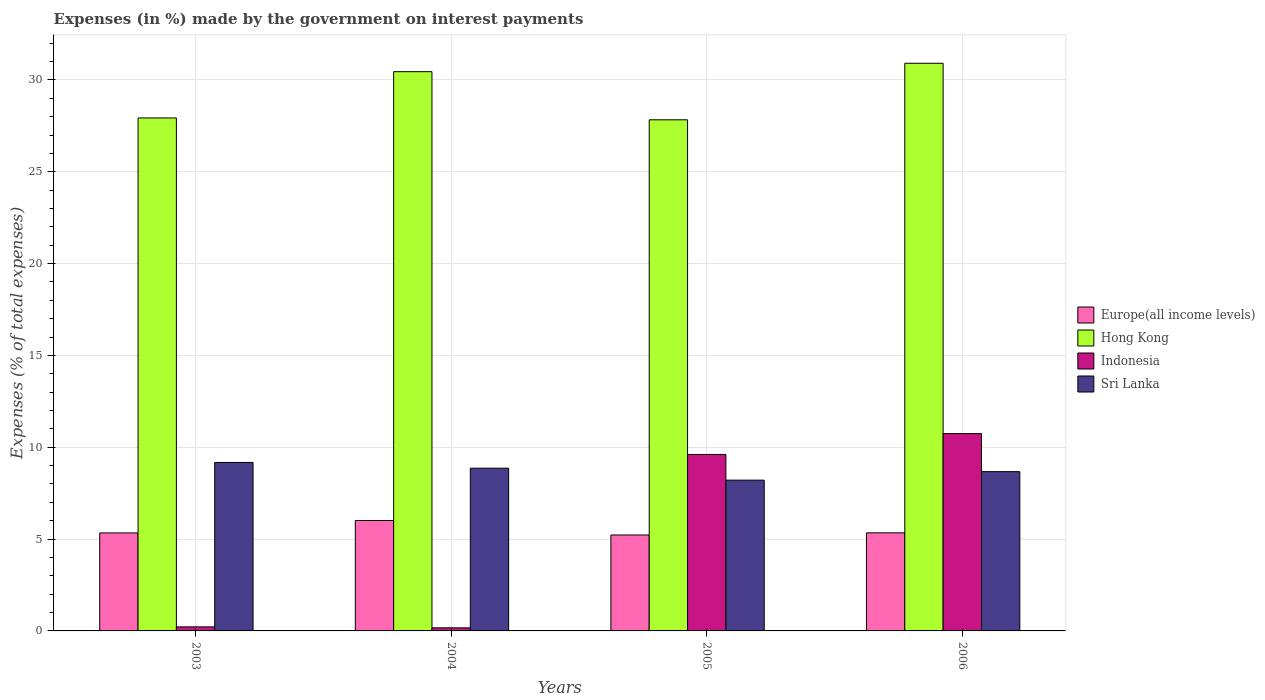How many different coloured bars are there?
Your answer should be very brief. 4. How many groups of bars are there?
Offer a terse response. 4. Are the number of bars on each tick of the X-axis equal?
Provide a succinct answer. Yes. How many bars are there on the 3rd tick from the left?
Keep it short and to the point. 4. How many bars are there on the 1st tick from the right?
Offer a terse response. 4. In how many cases, is the number of bars for a given year not equal to the number of legend labels?
Your response must be concise. 0. What is the percentage of expenses made by the government on interest payments in Indonesia in 2004?
Your answer should be very brief. 0.17. Across all years, what is the maximum percentage of expenses made by the government on interest payments in Indonesia?
Your answer should be very brief. 10.74. Across all years, what is the minimum percentage of expenses made by the government on interest payments in Sri Lanka?
Offer a very short reply. 8.21. In which year was the percentage of expenses made by the government on interest payments in Sri Lanka minimum?
Offer a terse response. 2005. What is the total percentage of expenses made by the government on interest payments in Europe(all income levels) in the graph?
Your answer should be compact. 21.91. What is the difference between the percentage of expenses made by the government on interest payments in Hong Kong in 2005 and that in 2006?
Give a very brief answer. -3.08. What is the difference between the percentage of expenses made by the government on interest payments in Sri Lanka in 2006 and the percentage of expenses made by the government on interest payments in Hong Kong in 2004?
Offer a terse response. -21.78. What is the average percentage of expenses made by the government on interest payments in Hong Kong per year?
Your answer should be compact. 29.28. In the year 2006, what is the difference between the percentage of expenses made by the government on interest payments in Europe(all income levels) and percentage of expenses made by the government on interest payments in Indonesia?
Your answer should be very brief. -5.4. What is the ratio of the percentage of expenses made by the government on interest payments in Europe(all income levels) in 2003 to that in 2005?
Provide a short and direct response. 1.02. Is the percentage of expenses made by the government on interest payments in Indonesia in 2004 less than that in 2006?
Your response must be concise. Yes. What is the difference between the highest and the second highest percentage of expenses made by the government on interest payments in Indonesia?
Provide a short and direct response. 1.14. What is the difference between the highest and the lowest percentage of expenses made by the government on interest payments in Europe(all income levels)?
Keep it short and to the point. 0.79. Is the sum of the percentage of expenses made by the government on interest payments in Hong Kong in 2004 and 2006 greater than the maximum percentage of expenses made by the government on interest payments in Sri Lanka across all years?
Ensure brevity in your answer.  Yes. Is it the case that in every year, the sum of the percentage of expenses made by the government on interest payments in Indonesia and percentage of expenses made by the government on interest payments in Europe(all income levels) is greater than the sum of percentage of expenses made by the government on interest payments in Hong Kong and percentage of expenses made by the government on interest payments in Sri Lanka?
Give a very brief answer. Yes. What does the 4th bar from the left in 2004 represents?
Ensure brevity in your answer.  Sri Lanka. What does the 4th bar from the right in 2004 represents?
Offer a terse response. Europe(all income levels). Is it the case that in every year, the sum of the percentage of expenses made by the government on interest payments in Hong Kong and percentage of expenses made by the government on interest payments in Indonesia is greater than the percentage of expenses made by the government on interest payments in Europe(all income levels)?
Make the answer very short. Yes. How many years are there in the graph?
Ensure brevity in your answer.  4. What is the difference between two consecutive major ticks on the Y-axis?
Provide a succinct answer. 5. Are the values on the major ticks of Y-axis written in scientific E-notation?
Your response must be concise. No. Does the graph contain grids?
Keep it short and to the point. Yes. Where does the legend appear in the graph?
Provide a succinct answer. Center right. How many legend labels are there?
Your response must be concise. 4. How are the legend labels stacked?
Keep it short and to the point. Vertical. What is the title of the graph?
Give a very brief answer. Expenses (in %) made by the government on interest payments. What is the label or title of the Y-axis?
Ensure brevity in your answer.  Expenses (% of total expenses). What is the Expenses (% of total expenses) in Europe(all income levels) in 2003?
Give a very brief answer. 5.34. What is the Expenses (% of total expenses) of Hong Kong in 2003?
Your response must be concise. 27.93. What is the Expenses (% of total expenses) of Indonesia in 2003?
Give a very brief answer. 0.22. What is the Expenses (% of total expenses) in Sri Lanka in 2003?
Your answer should be compact. 9.17. What is the Expenses (% of total expenses) of Europe(all income levels) in 2004?
Ensure brevity in your answer.  6.01. What is the Expenses (% of total expenses) in Hong Kong in 2004?
Keep it short and to the point. 30.45. What is the Expenses (% of total expenses) in Indonesia in 2004?
Your answer should be compact. 0.17. What is the Expenses (% of total expenses) in Sri Lanka in 2004?
Your answer should be very brief. 8.86. What is the Expenses (% of total expenses) of Europe(all income levels) in 2005?
Provide a short and direct response. 5.22. What is the Expenses (% of total expenses) of Hong Kong in 2005?
Offer a very short reply. 27.83. What is the Expenses (% of total expenses) of Indonesia in 2005?
Provide a succinct answer. 9.61. What is the Expenses (% of total expenses) of Sri Lanka in 2005?
Your answer should be very brief. 8.21. What is the Expenses (% of total expenses) of Europe(all income levels) in 2006?
Your answer should be compact. 5.34. What is the Expenses (% of total expenses) of Hong Kong in 2006?
Ensure brevity in your answer.  30.91. What is the Expenses (% of total expenses) of Indonesia in 2006?
Ensure brevity in your answer.  10.74. What is the Expenses (% of total expenses) in Sri Lanka in 2006?
Give a very brief answer. 8.67. Across all years, what is the maximum Expenses (% of total expenses) of Europe(all income levels)?
Keep it short and to the point. 6.01. Across all years, what is the maximum Expenses (% of total expenses) of Hong Kong?
Make the answer very short. 30.91. Across all years, what is the maximum Expenses (% of total expenses) in Indonesia?
Your answer should be compact. 10.74. Across all years, what is the maximum Expenses (% of total expenses) of Sri Lanka?
Provide a short and direct response. 9.17. Across all years, what is the minimum Expenses (% of total expenses) of Europe(all income levels)?
Provide a short and direct response. 5.22. Across all years, what is the minimum Expenses (% of total expenses) of Hong Kong?
Your response must be concise. 27.83. Across all years, what is the minimum Expenses (% of total expenses) in Indonesia?
Make the answer very short. 0.17. Across all years, what is the minimum Expenses (% of total expenses) of Sri Lanka?
Give a very brief answer. 8.21. What is the total Expenses (% of total expenses) of Europe(all income levels) in the graph?
Keep it short and to the point. 21.91. What is the total Expenses (% of total expenses) of Hong Kong in the graph?
Offer a very short reply. 117.12. What is the total Expenses (% of total expenses) of Indonesia in the graph?
Provide a short and direct response. 20.74. What is the total Expenses (% of total expenses) of Sri Lanka in the graph?
Your answer should be very brief. 34.92. What is the difference between the Expenses (% of total expenses) of Europe(all income levels) in 2003 and that in 2004?
Your answer should be compact. -0.68. What is the difference between the Expenses (% of total expenses) of Hong Kong in 2003 and that in 2004?
Give a very brief answer. -2.52. What is the difference between the Expenses (% of total expenses) of Indonesia in 2003 and that in 2004?
Make the answer very short. 0.05. What is the difference between the Expenses (% of total expenses) in Sri Lanka in 2003 and that in 2004?
Offer a terse response. 0.31. What is the difference between the Expenses (% of total expenses) of Europe(all income levels) in 2003 and that in 2005?
Your answer should be compact. 0.11. What is the difference between the Expenses (% of total expenses) of Hong Kong in 2003 and that in 2005?
Your response must be concise. 0.1. What is the difference between the Expenses (% of total expenses) of Indonesia in 2003 and that in 2005?
Offer a very short reply. -9.39. What is the difference between the Expenses (% of total expenses) in Sri Lanka in 2003 and that in 2005?
Provide a short and direct response. 0.96. What is the difference between the Expenses (% of total expenses) of Europe(all income levels) in 2003 and that in 2006?
Ensure brevity in your answer.  -0.01. What is the difference between the Expenses (% of total expenses) of Hong Kong in 2003 and that in 2006?
Provide a succinct answer. -2.98. What is the difference between the Expenses (% of total expenses) of Indonesia in 2003 and that in 2006?
Offer a very short reply. -10.53. What is the difference between the Expenses (% of total expenses) of Sri Lanka in 2003 and that in 2006?
Ensure brevity in your answer.  0.5. What is the difference between the Expenses (% of total expenses) in Europe(all income levels) in 2004 and that in 2005?
Your answer should be very brief. 0.79. What is the difference between the Expenses (% of total expenses) of Hong Kong in 2004 and that in 2005?
Offer a terse response. 2.62. What is the difference between the Expenses (% of total expenses) of Indonesia in 2004 and that in 2005?
Ensure brevity in your answer.  -9.44. What is the difference between the Expenses (% of total expenses) of Sri Lanka in 2004 and that in 2005?
Offer a very short reply. 0.65. What is the difference between the Expenses (% of total expenses) of Europe(all income levels) in 2004 and that in 2006?
Give a very brief answer. 0.67. What is the difference between the Expenses (% of total expenses) in Hong Kong in 2004 and that in 2006?
Your response must be concise. -0.46. What is the difference between the Expenses (% of total expenses) of Indonesia in 2004 and that in 2006?
Provide a short and direct response. -10.58. What is the difference between the Expenses (% of total expenses) of Sri Lanka in 2004 and that in 2006?
Provide a succinct answer. 0.19. What is the difference between the Expenses (% of total expenses) of Europe(all income levels) in 2005 and that in 2006?
Your answer should be compact. -0.12. What is the difference between the Expenses (% of total expenses) in Hong Kong in 2005 and that in 2006?
Provide a short and direct response. -3.08. What is the difference between the Expenses (% of total expenses) of Indonesia in 2005 and that in 2006?
Ensure brevity in your answer.  -1.14. What is the difference between the Expenses (% of total expenses) in Sri Lanka in 2005 and that in 2006?
Give a very brief answer. -0.46. What is the difference between the Expenses (% of total expenses) in Europe(all income levels) in 2003 and the Expenses (% of total expenses) in Hong Kong in 2004?
Provide a succinct answer. -25.12. What is the difference between the Expenses (% of total expenses) in Europe(all income levels) in 2003 and the Expenses (% of total expenses) in Indonesia in 2004?
Offer a terse response. 5.17. What is the difference between the Expenses (% of total expenses) in Europe(all income levels) in 2003 and the Expenses (% of total expenses) in Sri Lanka in 2004?
Make the answer very short. -3.53. What is the difference between the Expenses (% of total expenses) in Hong Kong in 2003 and the Expenses (% of total expenses) in Indonesia in 2004?
Provide a short and direct response. 27.76. What is the difference between the Expenses (% of total expenses) in Hong Kong in 2003 and the Expenses (% of total expenses) in Sri Lanka in 2004?
Keep it short and to the point. 19.07. What is the difference between the Expenses (% of total expenses) in Indonesia in 2003 and the Expenses (% of total expenses) in Sri Lanka in 2004?
Your answer should be compact. -8.64. What is the difference between the Expenses (% of total expenses) of Europe(all income levels) in 2003 and the Expenses (% of total expenses) of Hong Kong in 2005?
Keep it short and to the point. -22.5. What is the difference between the Expenses (% of total expenses) of Europe(all income levels) in 2003 and the Expenses (% of total expenses) of Indonesia in 2005?
Ensure brevity in your answer.  -4.27. What is the difference between the Expenses (% of total expenses) in Europe(all income levels) in 2003 and the Expenses (% of total expenses) in Sri Lanka in 2005?
Make the answer very short. -2.87. What is the difference between the Expenses (% of total expenses) of Hong Kong in 2003 and the Expenses (% of total expenses) of Indonesia in 2005?
Make the answer very short. 18.32. What is the difference between the Expenses (% of total expenses) in Hong Kong in 2003 and the Expenses (% of total expenses) in Sri Lanka in 2005?
Provide a succinct answer. 19.72. What is the difference between the Expenses (% of total expenses) of Indonesia in 2003 and the Expenses (% of total expenses) of Sri Lanka in 2005?
Offer a very short reply. -7.99. What is the difference between the Expenses (% of total expenses) of Europe(all income levels) in 2003 and the Expenses (% of total expenses) of Hong Kong in 2006?
Provide a short and direct response. -25.57. What is the difference between the Expenses (% of total expenses) of Europe(all income levels) in 2003 and the Expenses (% of total expenses) of Indonesia in 2006?
Your answer should be very brief. -5.41. What is the difference between the Expenses (% of total expenses) in Europe(all income levels) in 2003 and the Expenses (% of total expenses) in Sri Lanka in 2006?
Make the answer very short. -3.34. What is the difference between the Expenses (% of total expenses) in Hong Kong in 2003 and the Expenses (% of total expenses) in Indonesia in 2006?
Keep it short and to the point. 17.19. What is the difference between the Expenses (% of total expenses) of Hong Kong in 2003 and the Expenses (% of total expenses) of Sri Lanka in 2006?
Provide a short and direct response. 19.26. What is the difference between the Expenses (% of total expenses) of Indonesia in 2003 and the Expenses (% of total expenses) of Sri Lanka in 2006?
Ensure brevity in your answer.  -8.45. What is the difference between the Expenses (% of total expenses) of Europe(all income levels) in 2004 and the Expenses (% of total expenses) of Hong Kong in 2005?
Offer a terse response. -21.82. What is the difference between the Expenses (% of total expenses) of Europe(all income levels) in 2004 and the Expenses (% of total expenses) of Indonesia in 2005?
Provide a succinct answer. -3.6. What is the difference between the Expenses (% of total expenses) of Europe(all income levels) in 2004 and the Expenses (% of total expenses) of Sri Lanka in 2005?
Provide a short and direct response. -2.2. What is the difference between the Expenses (% of total expenses) in Hong Kong in 2004 and the Expenses (% of total expenses) in Indonesia in 2005?
Your answer should be compact. 20.84. What is the difference between the Expenses (% of total expenses) in Hong Kong in 2004 and the Expenses (% of total expenses) in Sri Lanka in 2005?
Provide a short and direct response. 22.24. What is the difference between the Expenses (% of total expenses) in Indonesia in 2004 and the Expenses (% of total expenses) in Sri Lanka in 2005?
Provide a succinct answer. -8.04. What is the difference between the Expenses (% of total expenses) of Europe(all income levels) in 2004 and the Expenses (% of total expenses) of Hong Kong in 2006?
Provide a succinct answer. -24.9. What is the difference between the Expenses (% of total expenses) in Europe(all income levels) in 2004 and the Expenses (% of total expenses) in Indonesia in 2006?
Your answer should be very brief. -4.73. What is the difference between the Expenses (% of total expenses) of Europe(all income levels) in 2004 and the Expenses (% of total expenses) of Sri Lanka in 2006?
Provide a succinct answer. -2.66. What is the difference between the Expenses (% of total expenses) in Hong Kong in 2004 and the Expenses (% of total expenses) in Indonesia in 2006?
Your response must be concise. 19.71. What is the difference between the Expenses (% of total expenses) of Hong Kong in 2004 and the Expenses (% of total expenses) of Sri Lanka in 2006?
Keep it short and to the point. 21.78. What is the difference between the Expenses (% of total expenses) of Indonesia in 2004 and the Expenses (% of total expenses) of Sri Lanka in 2006?
Your answer should be very brief. -8.5. What is the difference between the Expenses (% of total expenses) of Europe(all income levels) in 2005 and the Expenses (% of total expenses) of Hong Kong in 2006?
Make the answer very short. -25.69. What is the difference between the Expenses (% of total expenses) of Europe(all income levels) in 2005 and the Expenses (% of total expenses) of Indonesia in 2006?
Provide a succinct answer. -5.52. What is the difference between the Expenses (% of total expenses) of Europe(all income levels) in 2005 and the Expenses (% of total expenses) of Sri Lanka in 2006?
Your answer should be compact. -3.45. What is the difference between the Expenses (% of total expenses) in Hong Kong in 2005 and the Expenses (% of total expenses) in Indonesia in 2006?
Offer a terse response. 17.09. What is the difference between the Expenses (% of total expenses) of Hong Kong in 2005 and the Expenses (% of total expenses) of Sri Lanka in 2006?
Your answer should be very brief. 19.16. What is the difference between the Expenses (% of total expenses) of Indonesia in 2005 and the Expenses (% of total expenses) of Sri Lanka in 2006?
Your response must be concise. 0.94. What is the average Expenses (% of total expenses) of Europe(all income levels) per year?
Your answer should be very brief. 5.48. What is the average Expenses (% of total expenses) of Hong Kong per year?
Your answer should be very brief. 29.28. What is the average Expenses (% of total expenses) of Indonesia per year?
Make the answer very short. 5.19. What is the average Expenses (% of total expenses) in Sri Lanka per year?
Ensure brevity in your answer.  8.73. In the year 2003, what is the difference between the Expenses (% of total expenses) in Europe(all income levels) and Expenses (% of total expenses) in Hong Kong?
Make the answer very short. -22.6. In the year 2003, what is the difference between the Expenses (% of total expenses) in Europe(all income levels) and Expenses (% of total expenses) in Indonesia?
Keep it short and to the point. 5.12. In the year 2003, what is the difference between the Expenses (% of total expenses) of Europe(all income levels) and Expenses (% of total expenses) of Sri Lanka?
Keep it short and to the point. -3.84. In the year 2003, what is the difference between the Expenses (% of total expenses) in Hong Kong and Expenses (% of total expenses) in Indonesia?
Your response must be concise. 27.71. In the year 2003, what is the difference between the Expenses (% of total expenses) in Hong Kong and Expenses (% of total expenses) in Sri Lanka?
Your response must be concise. 18.76. In the year 2003, what is the difference between the Expenses (% of total expenses) in Indonesia and Expenses (% of total expenses) in Sri Lanka?
Keep it short and to the point. -8.95. In the year 2004, what is the difference between the Expenses (% of total expenses) in Europe(all income levels) and Expenses (% of total expenses) in Hong Kong?
Your answer should be compact. -24.44. In the year 2004, what is the difference between the Expenses (% of total expenses) of Europe(all income levels) and Expenses (% of total expenses) of Indonesia?
Make the answer very short. 5.84. In the year 2004, what is the difference between the Expenses (% of total expenses) of Europe(all income levels) and Expenses (% of total expenses) of Sri Lanka?
Offer a terse response. -2.85. In the year 2004, what is the difference between the Expenses (% of total expenses) in Hong Kong and Expenses (% of total expenses) in Indonesia?
Provide a short and direct response. 30.28. In the year 2004, what is the difference between the Expenses (% of total expenses) of Hong Kong and Expenses (% of total expenses) of Sri Lanka?
Your answer should be compact. 21.59. In the year 2004, what is the difference between the Expenses (% of total expenses) of Indonesia and Expenses (% of total expenses) of Sri Lanka?
Offer a very short reply. -8.69. In the year 2005, what is the difference between the Expenses (% of total expenses) of Europe(all income levels) and Expenses (% of total expenses) of Hong Kong?
Provide a short and direct response. -22.61. In the year 2005, what is the difference between the Expenses (% of total expenses) in Europe(all income levels) and Expenses (% of total expenses) in Indonesia?
Your answer should be very brief. -4.39. In the year 2005, what is the difference between the Expenses (% of total expenses) of Europe(all income levels) and Expenses (% of total expenses) of Sri Lanka?
Ensure brevity in your answer.  -2.99. In the year 2005, what is the difference between the Expenses (% of total expenses) of Hong Kong and Expenses (% of total expenses) of Indonesia?
Offer a terse response. 18.22. In the year 2005, what is the difference between the Expenses (% of total expenses) in Hong Kong and Expenses (% of total expenses) in Sri Lanka?
Offer a very short reply. 19.62. In the year 2005, what is the difference between the Expenses (% of total expenses) of Indonesia and Expenses (% of total expenses) of Sri Lanka?
Your response must be concise. 1.4. In the year 2006, what is the difference between the Expenses (% of total expenses) in Europe(all income levels) and Expenses (% of total expenses) in Hong Kong?
Your response must be concise. -25.57. In the year 2006, what is the difference between the Expenses (% of total expenses) in Europe(all income levels) and Expenses (% of total expenses) in Indonesia?
Your response must be concise. -5.4. In the year 2006, what is the difference between the Expenses (% of total expenses) of Europe(all income levels) and Expenses (% of total expenses) of Sri Lanka?
Your response must be concise. -3.33. In the year 2006, what is the difference between the Expenses (% of total expenses) in Hong Kong and Expenses (% of total expenses) in Indonesia?
Keep it short and to the point. 20.17. In the year 2006, what is the difference between the Expenses (% of total expenses) in Hong Kong and Expenses (% of total expenses) in Sri Lanka?
Your answer should be very brief. 22.24. In the year 2006, what is the difference between the Expenses (% of total expenses) of Indonesia and Expenses (% of total expenses) of Sri Lanka?
Your answer should be compact. 2.07. What is the ratio of the Expenses (% of total expenses) in Europe(all income levels) in 2003 to that in 2004?
Ensure brevity in your answer.  0.89. What is the ratio of the Expenses (% of total expenses) in Hong Kong in 2003 to that in 2004?
Keep it short and to the point. 0.92. What is the ratio of the Expenses (% of total expenses) of Indonesia in 2003 to that in 2004?
Your answer should be very brief. 1.31. What is the ratio of the Expenses (% of total expenses) in Sri Lanka in 2003 to that in 2004?
Offer a very short reply. 1.04. What is the ratio of the Expenses (% of total expenses) in Europe(all income levels) in 2003 to that in 2005?
Offer a very short reply. 1.02. What is the ratio of the Expenses (% of total expenses) in Hong Kong in 2003 to that in 2005?
Offer a terse response. 1. What is the ratio of the Expenses (% of total expenses) in Indonesia in 2003 to that in 2005?
Your answer should be compact. 0.02. What is the ratio of the Expenses (% of total expenses) of Sri Lanka in 2003 to that in 2005?
Keep it short and to the point. 1.12. What is the ratio of the Expenses (% of total expenses) in Europe(all income levels) in 2003 to that in 2006?
Keep it short and to the point. 1. What is the ratio of the Expenses (% of total expenses) of Hong Kong in 2003 to that in 2006?
Give a very brief answer. 0.9. What is the ratio of the Expenses (% of total expenses) of Indonesia in 2003 to that in 2006?
Your answer should be compact. 0.02. What is the ratio of the Expenses (% of total expenses) in Sri Lanka in 2003 to that in 2006?
Provide a succinct answer. 1.06. What is the ratio of the Expenses (% of total expenses) of Europe(all income levels) in 2004 to that in 2005?
Your answer should be very brief. 1.15. What is the ratio of the Expenses (% of total expenses) of Hong Kong in 2004 to that in 2005?
Keep it short and to the point. 1.09. What is the ratio of the Expenses (% of total expenses) in Indonesia in 2004 to that in 2005?
Ensure brevity in your answer.  0.02. What is the ratio of the Expenses (% of total expenses) in Sri Lanka in 2004 to that in 2005?
Ensure brevity in your answer.  1.08. What is the ratio of the Expenses (% of total expenses) of Europe(all income levels) in 2004 to that in 2006?
Offer a very short reply. 1.13. What is the ratio of the Expenses (% of total expenses) of Hong Kong in 2004 to that in 2006?
Your answer should be very brief. 0.99. What is the ratio of the Expenses (% of total expenses) in Indonesia in 2004 to that in 2006?
Your answer should be very brief. 0.02. What is the ratio of the Expenses (% of total expenses) of Sri Lanka in 2004 to that in 2006?
Ensure brevity in your answer.  1.02. What is the ratio of the Expenses (% of total expenses) in Europe(all income levels) in 2005 to that in 2006?
Your answer should be very brief. 0.98. What is the ratio of the Expenses (% of total expenses) in Hong Kong in 2005 to that in 2006?
Give a very brief answer. 0.9. What is the ratio of the Expenses (% of total expenses) in Indonesia in 2005 to that in 2006?
Make the answer very short. 0.89. What is the ratio of the Expenses (% of total expenses) in Sri Lanka in 2005 to that in 2006?
Your response must be concise. 0.95. What is the difference between the highest and the second highest Expenses (% of total expenses) of Europe(all income levels)?
Offer a very short reply. 0.67. What is the difference between the highest and the second highest Expenses (% of total expenses) in Hong Kong?
Make the answer very short. 0.46. What is the difference between the highest and the second highest Expenses (% of total expenses) in Indonesia?
Make the answer very short. 1.14. What is the difference between the highest and the second highest Expenses (% of total expenses) of Sri Lanka?
Provide a short and direct response. 0.31. What is the difference between the highest and the lowest Expenses (% of total expenses) in Europe(all income levels)?
Make the answer very short. 0.79. What is the difference between the highest and the lowest Expenses (% of total expenses) of Hong Kong?
Give a very brief answer. 3.08. What is the difference between the highest and the lowest Expenses (% of total expenses) of Indonesia?
Your answer should be very brief. 10.58. What is the difference between the highest and the lowest Expenses (% of total expenses) of Sri Lanka?
Provide a short and direct response. 0.96. 